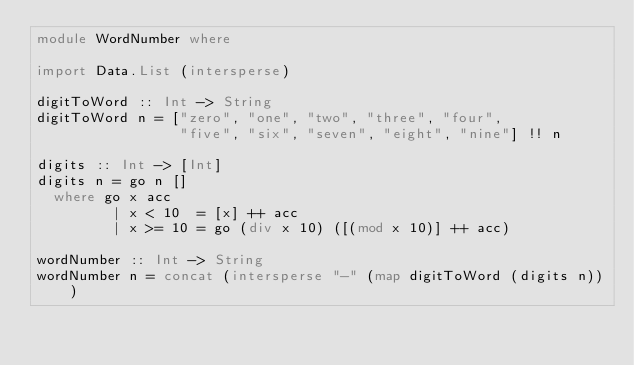Convert code to text. <code><loc_0><loc_0><loc_500><loc_500><_Haskell_>module WordNumber where

import Data.List (intersperse)

digitToWord :: Int -> String
digitToWord n = ["zero", "one", "two", "three", "four",
                 "five", "six", "seven", "eight", "nine"] !! n
           
digits :: Int -> [Int]
digits n = go n []
  where go x acc
         | x < 10  = [x] ++ acc
         | x >= 10 = go (div x 10) ([(mod x 10)] ++ acc)

wordNumber :: Int -> String
wordNumber n = concat (intersperse "-" (map digitToWord (digits n)))
</code> 